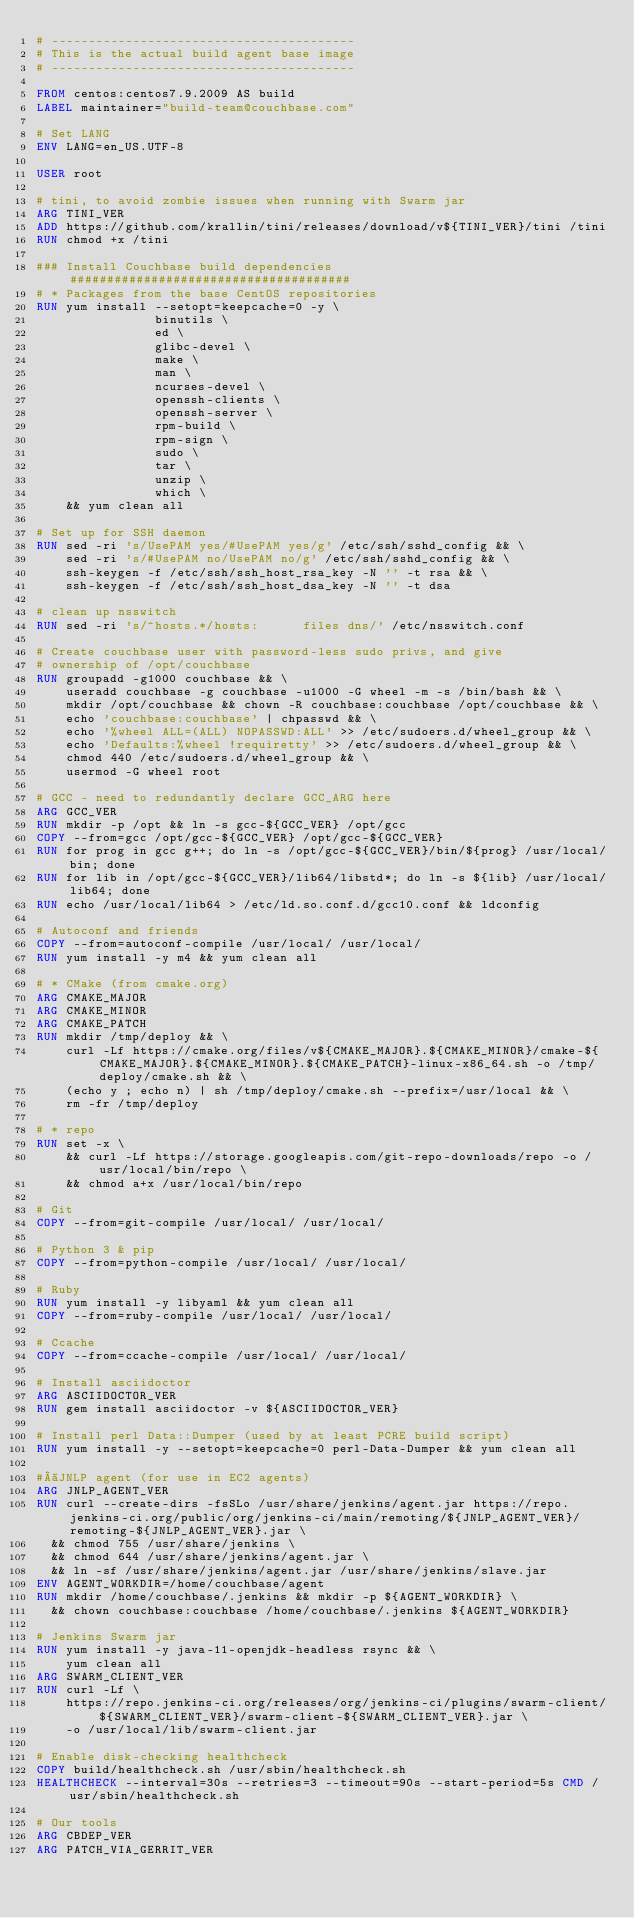<code> <loc_0><loc_0><loc_500><loc_500><_Dockerfile_># -----------------------------------------
# This is the actual build agent base image
# -----------------------------------------

FROM centos:centos7.9.2009 AS build
LABEL maintainer="build-team@couchbase.com"

# Set LANG
ENV LANG=en_US.UTF-8

USER root

# tini, to avoid zombie issues when running with Swarm jar
ARG TINI_VER
ADD https://github.com/krallin/tini/releases/download/v${TINI_VER}/tini /tini
RUN chmod +x /tini

### Install Couchbase build dependencies ######################################
# * Packages from the base CentOS repositories
RUN yum install --setopt=keepcache=0 -y \
                binutils \
                ed \
                glibc-devel \
                make \
                man \
                ncurses-devel \
                openssh-clients \
                openssh-server \
                rpm-build \
                rpm-sign \
                sudo \
                tar \
                unzip \
                which \
    && yum clean all

# Set up for SSH daemon
RUN sed -ri 's/UsePAM yes/#UsePAM yes/g' /etc/ssh/sshd_config && \
    sed -ri 's/#UsePAM no/UsePAM no/g' /etc/ssh/sshd_config && \
    ssh-keygen -f /etc/ssh/ssh_host_rsa_key -N '' -t rsa && \
    ssh-keygen -f /etc/ssh/ssh_host_dsa_key -N '' -t dsa

# clean up nsswitch
RUN sed -ri 's/^hosts.*/hosts:      files dns/' /etc/nsswitch.conf

# Create couchbase user with password-less sudo privs, and give
# ownership of /opt/couchbase
RUN groupadd -g1000 couchbase && \
    useradd couchbase -g couchbase -u1000 -G wheel -m -s /bin/bash && \
    mkdir /opt/couchbase && chown -R couchbase:couchbase /opt/couchbase && \
    echo 'couchbase:couchbase' | chpasswd && \
    echo '%wheel ALL=(ALL) NOPASSWD:ALL' >> /etc/sudoers.d/wheel_group && \
    echo 'Defaults:%wheel !requiretty' >> /etc/sudoers.d/wheel_group && \
    chmod 440 /etc/sudoers.d/wheel_group && \
    usermod -G wheel root

# GCC - need to redundantly declare GCC_ARG here
ARG GCC_VER
RUN mkdir -p /opt && ln -s gcc-${GCC_VER} /opt/gcc
COPY --from=gcc /opt/gcc-${GCC_VER} /opt/gcc-${GCC_VER}
RUN for prog in gcc g++; do ln -s /opt/gcc-${GCC_VER}/bin/${prog} /usr/local/bin; done
RUN for lib in /opt/gcc-${GCC_VER}/lib64/libstd*; do ln -s ${lib} /usr/local/lib64; done
RUN echo /usr/local/lib64 > /etc/ld.so.conf.d/gcc10.conf && ldconfig

# Autoconf and friends
COPY --from=autoconf-compile /usr/local/ /usr/local/
RUN yum install -y m4 && yum clean all

# * CMake (from cmake.org)
ARG CMAKE_MAJOR
ARG CMAKE_MINOR
ARG CMAKE_PATCH
RUN mkdir /tmp/deploy && \
    curl -Lf https://cmake.org/files/v${CMAKE_MAJOR}.${CMAKE_MINOR}/cmake-${CMAKE_MAJOR}.${CMAKE_MINOR}.${CMAKE_PATCH}-linux-x86_64.sh -o /tmp/deploy/cmake.sh && \
    (echo y ; echo n) | sh /tmp/deploy/cmake.sh --prefix=/usr/local && \
    rm -fr /tmp/deploy

# * repo
RUN set -x \
    && curl -Lf https://storage.googleapis.com/git-repo-downloads/repo -o /usr/local/bin/repo \
    && chmod a+x /usr/local/bin/repo

# Git
COPY --from=git-compile /usr/local/ /usr/local/

# Python 3 & pip
COPY --from=python-compile /usr/local/ /usr/local/

# Ruby
RUN yum install -y libyaml && yum clean all
COPY --from=ruby-compile /usr/local/ /usr/local/

# Ccache
COPY --from=ccache-compile /usr/local/ /usr/local/

# Install asciidoctor
ARG ASCIIDOCTOR_VER
RUN gem install asciidoctor -v ${ASCIIDOCTOR_VER}

# Install perl Data::Dumper (used by at least PCRE build script)
RUN yum install -y --setopt=keepcache=0 perl-Data-Dumper && yum clean all

# JNLP agent (for use in EC2 agents)
ARG JNLP_AGENT_VER
RUN curl --create-dirs -fsSLo /usr/share/jenkins/agent.jar https://repo.jenkins-ci.org/public/org/jenkins-ci/main/remoting/${JNLP_AGENT_VER}/remoting-${JNLP_AGENT_VER}.jar \
  && chmod 755 /usr/share/jenkins \
  && chmod 644 /usr/share/jenkins/agent.jar \
  && ln -sf /usr/share/jenkins/agent.jar /usr/share/jenkins/slave.jar
ENV AGENT_WORKDIR=/home/couchbase/agent
RUN mkdir /home/couchbase/.jenkins && mkdir -p ${AGENT_WORKDIR} \
  && chown couchbase:couchbase /home/couchbase/.jenkins ${AGENT_WORKDIR}

# Jenkins Swarm jar
RUN yum install -y java-11-openjdk-headless rsync && \
    yum clean all
ARG SWARM_CLIENT_VER
RUN curl -Lf \
    https://repo.jenkins-ci.org/releases/org/jenkins-ci/plugins/swarm-client/${SWARM_CLIENT_VER}/swarm-client-${SWARM_CLIENT_VER}.jar \
    -o /usr/local/lib/swarm-client.jar

# Enable disk-checking healthcheck
COPY build/healthcheck.sh /usr/sbin/healthcheck.sh
HEALTHCHECK --interval=30s --retries=3 --timeout=90s --start-period=5s CMD /usr/sbin/healthcheck.sh

# Our tools
ARG CBDEP_VER
ARG PATCH_VIA_GERRIT_VER</code> 